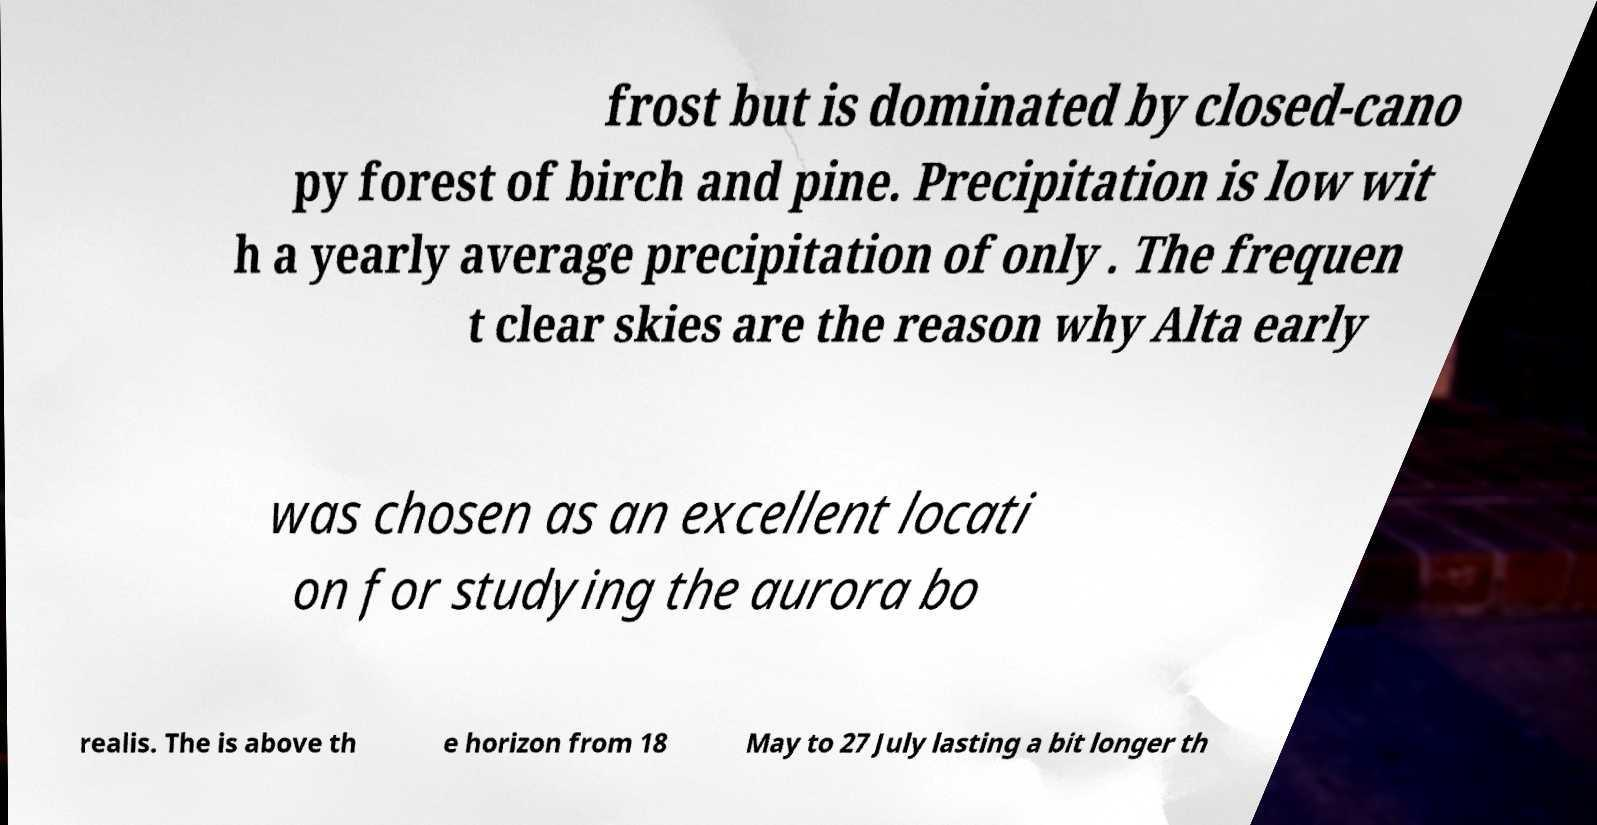Could you extract and type out the text from this image? frost but is dominated by closed-cano py forest of birch and pine. Precipitation is low wit h a yearly average precipitation of only . The frequen t clear skies are the reason why Alta early was chosen as an excellent locati on for studying the aurora bo realis. The is above th e horizon from 18 May to 27 July lasting a bit longer th 